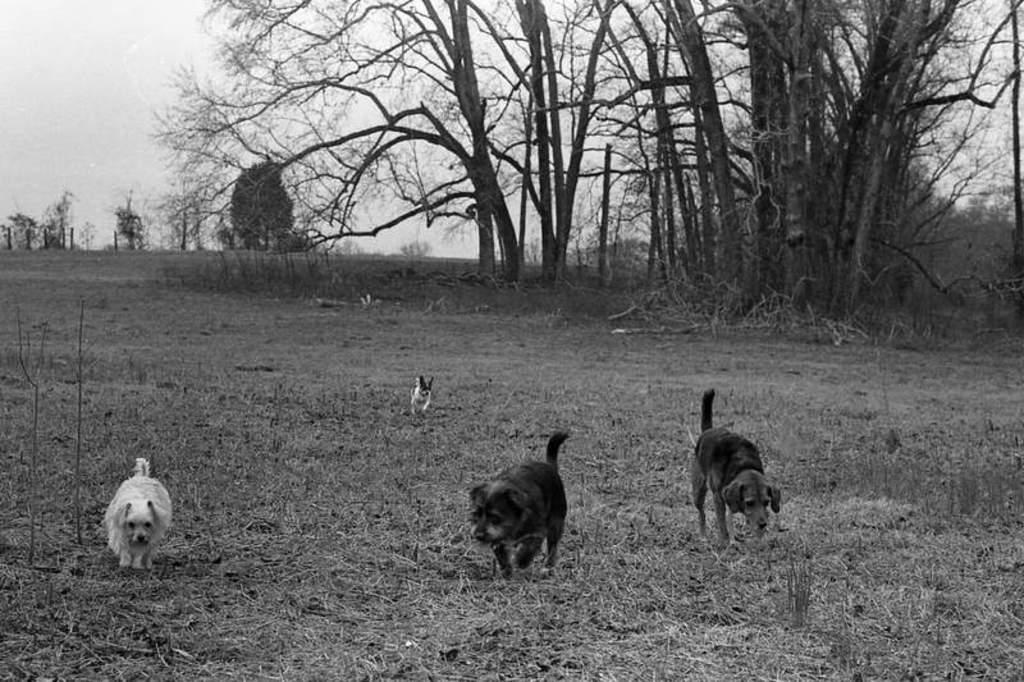In one or two sentences, can you explain what this image depicts? In this picture there is a black and white photography of the dogs in the ground. Behind there are some dry trees. 